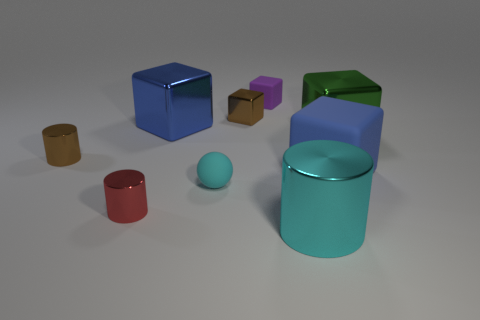Add 1 blue matte objects. How many objects exist? 10 Subtract all cylinders. How many objects are left? 6 Add 5 tiny spheres. How many tiny spheres are left? 6 Add 8 large green shiny things. How many large green shiny things exist? 9 Subtract 1 brown cylinders. How many objects are left? 8 Subtract all cyan spheres. Subtract all tiny purple matte objects. How many objects are left? 7 